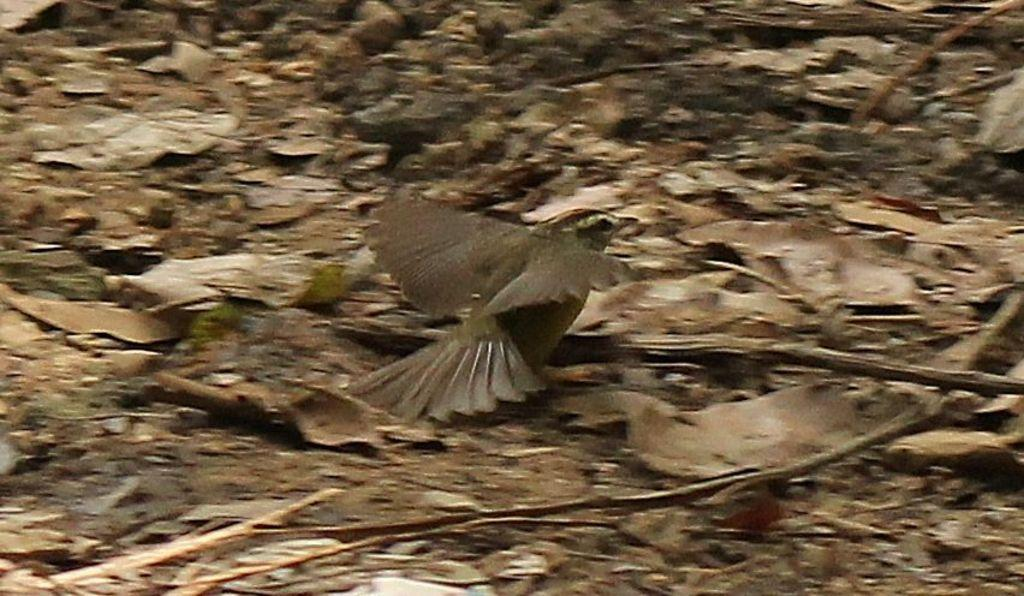What type of animal is in the image? There is a bird in the image. What color is the bird? The bird is brown in color. What can be seen in the background of the image? The background of the image is brown. How many waves can be seen in the image? There are no waves present in the image. What type of card is being used by the bird in the image? There is no card present in the image, and the bird is not using any object. 